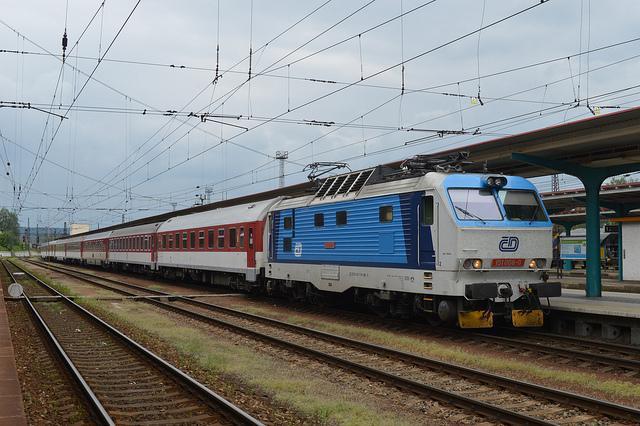How many train cars?
Give a very brief answer. 8. How many rails are there?
Give a very brief answer. 3. How many sets of tracks are there?
Give a very brief answer. 3. How many sets of track are there?
Give a very brief answer. 3. How many trains are there?
Give a very brief answer. 1. How many train tracks are there?
Give a very brief answer. 3. How many tracks are there?
Give a very brief answer. 3. How many cars are on this train?
Give a very brief answer. 8. How many people are wearing glasses?
Give a very brief answer. 0. 